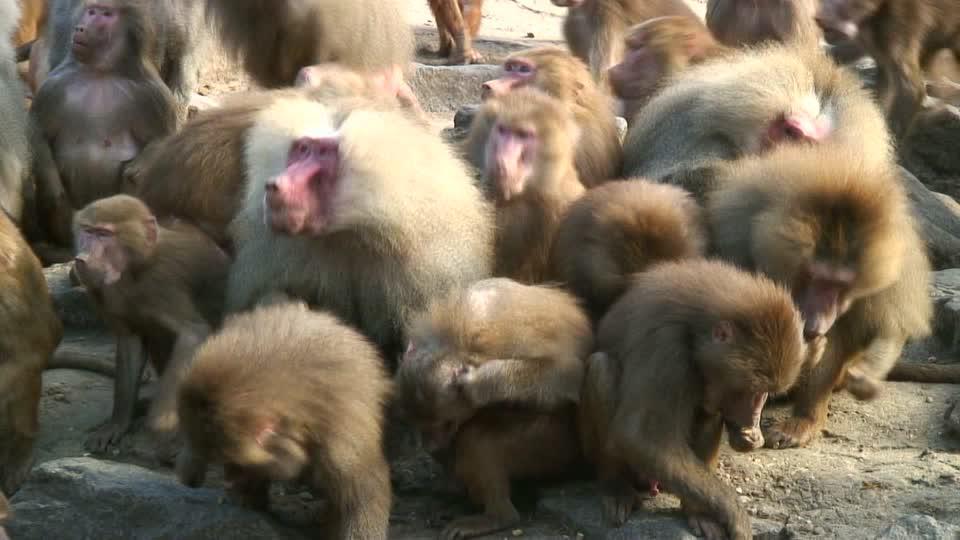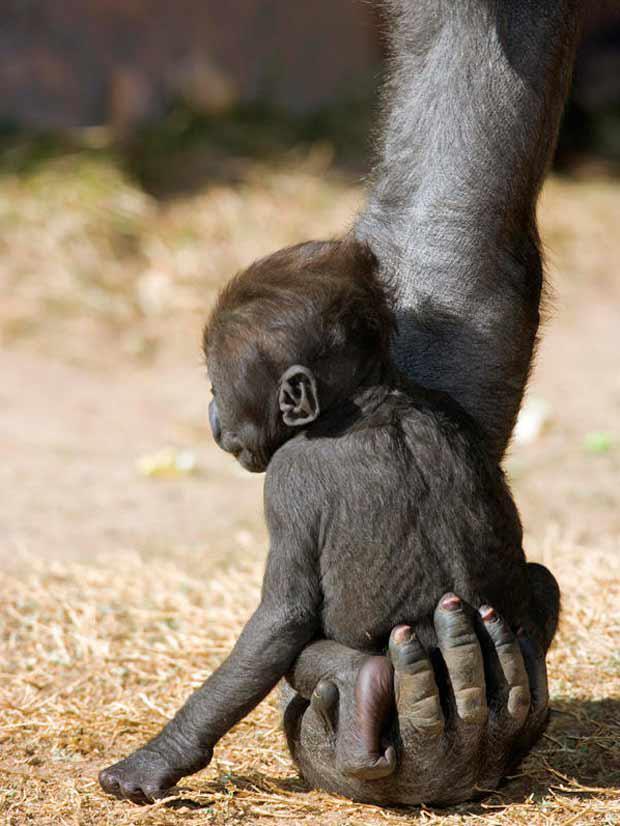The first image is the image on the left, the second image is the image on the right. Analyze the images presented: Is the assertion "There is at least two primates in the left image." valid? Answer yes or no. Yes. The first image is the image on the left, the second image is the image on the right. Analyze the images presented: Is the assertion "Each animal in one of the images is a different species." valid? Answer yes or no. No. 